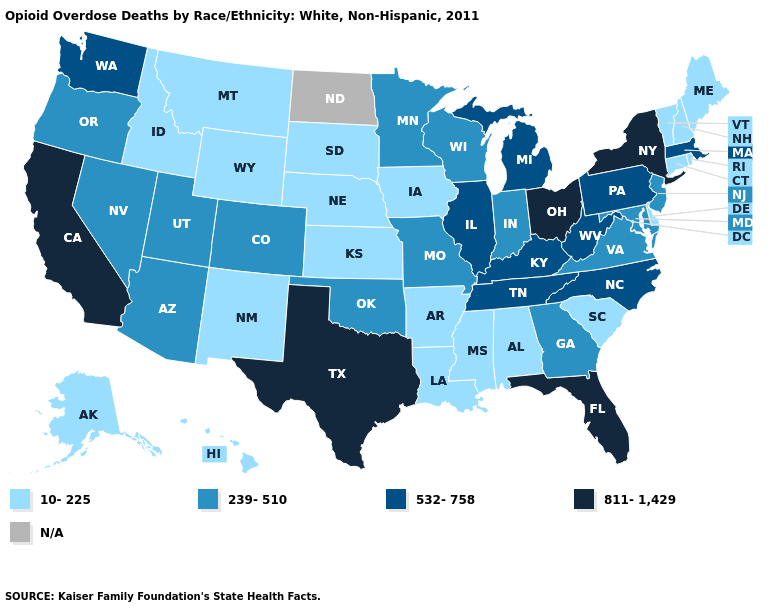Does the map have missing data?
Keep it brief. Yes. What is the value of Montana?
Keep it brief. 10-225. Among the states that border Michigan , does Wisconsin have the lowest value?
Write a very short answer. Yes. Does South Dakota have the lowest value in the MidWest?
Answer briefly. Yes. Does Louisiana have the highest value in the USA?
Give a very brief answer. No. What is the value of Alabama?
Quick response, please. 10-225. Does New York have the highest value in the Northeast?
Write a very short answer. Yes. Does California have the highest value in the USA?
Quick response, please. Yes. What is the value of Utah?
Give a very brief answer. 239-510. Is the legend a continuous bar?
Quick response, please. No. What is the value of California?
Be succinct. 811-1,429. What is the value of Oklahoma?
Give a very brief answer. 239-510. Does Georgia have the lowest value in the USA?
Write a very short answer. No. What is the lowest value in the MidWest?
Answer briefly. 10-225. Name the states that have a value in the range 239-510?
Keep it brief. Arizona, Colorado, Georgia, Indiana, Maryland, Minnesota, Missouri, Nevada, New Jersey, Oklahoma, Oregon, Utah, Virginia, Wisconsin. 